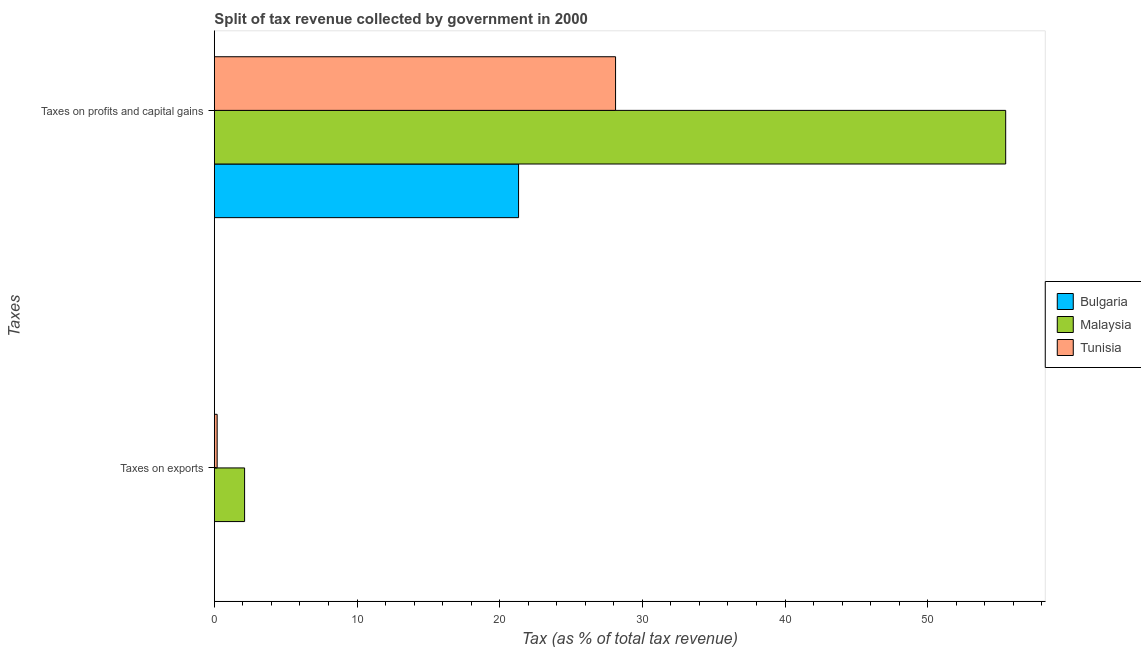How many groups of bars are there?
Your answer should be compact. 2. Are the number of bars per tick equal to the number of legend labels?
Provide a short and direct response. Yes. Are the number of bars on each tick of the Y-axis equal?
Keep it short and to the point. Yes. How many bars are there on the 2nd tick from the top?
Your answer should be compact. 3. What is the label of the 2nd group of bars from the top?
Provide a succinct answer. Taxes on exports. What is the percentage of revenue obtained from taxes on exports in Malaysia?
Give a very brief answer. 2.12. Across all countries, what is the maximum percentage of revenue obtained from taxes on exports?
Your answer should be very brief. 2.12. Across all countries, what is the minimum percentage of revenue obtained from taxes on profits and capital gains?
Keep it short and to the point. 21.32. In which country was the percentage of revenue obtained from taxes on exports maximum?
Keep it short and to the point. Malaysia. What is the total percentage of revenue obtained from taxes on exports in the graph?
Offer a very short reply. 2.32. What is the difference between the percentage of revenue obtained from taxes on exports in Tunisia and that in Bulgaria?
Provide a short and direct response. 0.2. What is the difference between the percentage of revenue obtained from taxes on exports in Bulgaria and the percentage of revenue obtained from taxes on profits and capital gains in Tunisia?
Give a very brief answer. -28.12. What is the average percentage of revenue obtained from taxes on profits and capital gains per country?
Make the answer very short. 34.97. What is the difference between the percentage of revenue obtained from taxes on exports and percentage of revenue obtained from taxes on profits and capital gains in Tunisia?
Your response must be concise. -27.92. What is the ratio of the percentage of revenue obtained from taxes on profits and capital gains in Bulgaria to that in Tunisia?
Offer a terse response. 0.76. Is the percentage of revenue obtained from taxes on exports in Bulgaria less than that in Malaysia?
Provide a succinct answer. Yes. What does the 2nd bar from the top in Taxes on profits and capital gains represents?
Provide a short and direct response. Malaysia. What does the 3rd bar from the bottom in Taxes on profits and capital gains represents?
Ensure brevity in your answer.  Tunisia. Are all the bars in the graph horizontal?
Give a very brief answer. Yes. How many countries are there in the graph?
Offer a terse response. 3. What is the difference between two consecutive major ticks on the X-axis?
Give a very brief answer. 10. Are the values on the major ticks of X-axis written in scientific E-notation?
Keep it short and to the point. No. Does the graph contain any zero values?
Ensure brevity in your answer.  No. How are the legend labels stacked?
Your answer should be compact. Vertical. What is the title of the graph?
Make the answer very short. Split of tax revenue collected by government in 2000. What is the label or title of the X-axis?
Your answer should be compact. Tax (as % of total tax revenue). What is the label or title of the Y-axis?
Your answer should be very brief. Taxes. What is the Tax (as % of total tax revenue) of Bulgaria in Taxes on exports?
Give a very brief answer. 0. What is the Tax (as % of total tax revenue) in Malaysia in Taxes on exports?
Ensure brevity in your answer.  2.12. What is the Tax (as % of total tax revenue) of Tunisia in Taxes on exports?
Your response must be concise. 0.2. What is the Tax (as % of total tax revenue) in Bulgaria in Taxes on profits and capital gains?
Provide a succinct answer. 21.32. What is the Tax (as % of total tax revenue) of Malaysia in Taxes on profits and capital gains?
Offer a very short reply. 55.46. What is the Tax (as % of total tax revenue) of Tunisia in Taxes on profits and capital gains?
Make the answer very short. 28.12. Across all Taxes, what is the maximum Tax (as % of total tax revenue) of Bulgaria?
Your answer should be compact. 21.32. Across all Taxes, what is the maximum Tax (as % of total tax revenue) in Malaysia?
Make the answer very short. 55.46. Across all Taxes, what is the maximum Tax (as % of total tax revenue) in Tunisia?
Provide a succinct answer. 28.12. Across all Taxes, what is the minimum Tax (as % of total tax revenue) in Bulgaria?
Keep it short and to the point. 0. Across all Taxes, what is the minimum Tax (as % of total tax revenue) of Malaysia?
Your answer should be very brief. 2.12. Across all Taxes, what is the minimum Tax (as % of total tax revenue) of Tunisia?
Offer a terse response. 0.2. What is the total Tax (as % of total tax revenue) of Bulgaria in the graph?
Offer a terse response. 21.32. What is the total Tax (as % of total tax revenue) in Malaysia in the graph?
Give a very brief answer. 57.58. What is the total Tax (as % of total tax revenue) in Tunisia in the graph?
Provide a succinct answer. 28.32. What is the difference between the Tax (as % of total tax revenue) in Bulgaria in Taxes on exports and that in Taxes on profits and capital gains?
Provide a succinct answer. -21.32. What is the difference between the Tax (as % of total tax revenue) of Malaysia in Taxes on exports and that in Taxes on profits and capital gains?
Provide a succinct answer. -53.34. What is the difference between the Tax (as % of total tax revenue) in Tunisia in Taxes on exports and that in Taxes on profits and capital gains?
Your answer should be compact. -27.92. What is the difference between the Tax (as % of total tax revenue) of Bulgaria in Taxes on exports and the Tax (as % of total tax revenue) of Malaysia in Taxes on profits and capital gains?
Offer a very short reply. -55.46. What is the difference between the Tax (as % of total tax revenue) in Bulgaria in Taxes on exports and the Tax (as % of total tax revenue) in Tunisia in Taxes on profits and capital gains?
Your answer should be very brief. -28.12. What is the difference between the Tax (as % of total tax revenue) in Malaysia in Taxes on exports and the Tax (as % of total tax revenue) in Tunisia in Taxes on profits and capital gains?
Give a very brief answer. -26. What is the average Tax (as % of total tax revenue) in Bulgaria per Taxes?
Give a very brief answer. 10.66. What is the average Tax (as % of total tax revenue) in Malaysia per Taxes?
Offer a terse response. 28.79. What is the average Tax (as % of total tax revenue) of Tunisia per Taxes?
Your answer should be very brief. 14.16. What is the difference between the Tax (as % of total tax revenue) in Bulgaria and Tax (as % of total tax revenue) in Malaysia in Taxes on exports?
Offer a terse response. -2.12. What is the difference between the Tax (as % of total tax revenue) of Bulgaria and Tax (as % of total tax revenue) of Tunisia in Taxes on exports?
Keep it short and to the point. -0.2. What is the difference between the Tax (as % of total tax revenue) of Malaysia and Tax (as % of total tax revenue) of Tunisia in Taxes on exports?
Provide a succinct answer. 1.92. What is the difference between the Tax (as % of total tax revenue) of Bulgaria and Tax (as % of total tax revenue) of Malaysia in Taxes on profits and capital gains?
Make the answer very short. -34.14. What is the difference between the Tax (as % of total tax revenue) of Bulgaria and Tax (as % of total tax revenue) of Tunisia in Taxes on profits and capital gains?
Ensure brevity in your answer.  -6.8. What is the difference between the Tax (as % of total tax revenue) in Malaysia and Tax (as % of total tax revenue) in Tunisia in Taxes on profits and capital gains?
Ensure brevity in your answer.  27.34. What is the ratio of the Tax (as % of total tax revenue) in Bulgaria in Taxes on exports to that in Taxes on profits and capital gains?
Your answer should be compact. 0. What is the ratio of the Tax (as % of total tax revenue) of Malaysia in Taxes on exports to that in Taxes on profits and capital gains?
Offer a terse response. 0.04. What is the ratio of the Tax (as % of total tax revenue) of Tunisia in Taxes on exports to that in Taxes on profits and capital gains?
Ensure brevity in your answer.  0.01. What is the difference between the highest and the second highest Tax (as % of total tax revenue) in Bulgaria?
Your answer should be compact. 21.32. What is the difference between the highest and the second highest Tax (as % of total tax revenue) in Malaysia?
Give a very brief answer. 53.34. What is the difference between the highest and the second highest Tax (as % of total tax revenue) in Tunisia?
Your answer should be compact. 27.92. What is the difference between the highest and the lowest Tax (as % of total tax revenue) in Bulgaria?
Provide a short and direct response. 21.32. What is the difference between the highest and the lowest Tax (as % of total tax revenue) in Malaysia?
Ensure brevity in your answer.  53.34. What is the difference between the highest and the lowest Tax (as % of total tax revenue) of Tunisia?
Provide a succinct answer. 27.92. 